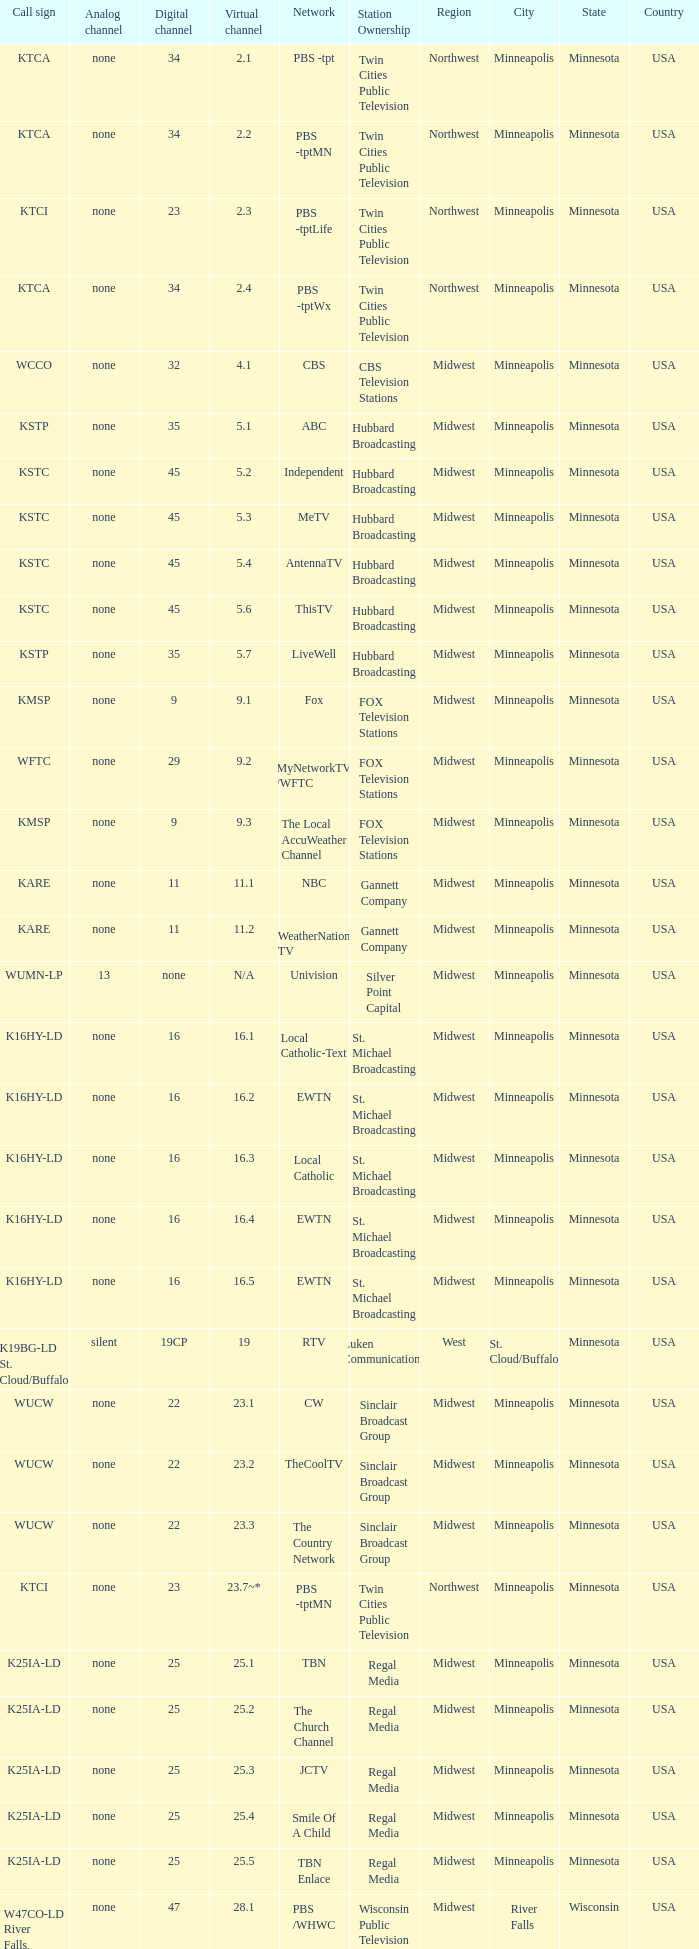Station Ownership of eicb tv, and a Call sign of ktcj-ld is what virtual network? 50.1. 